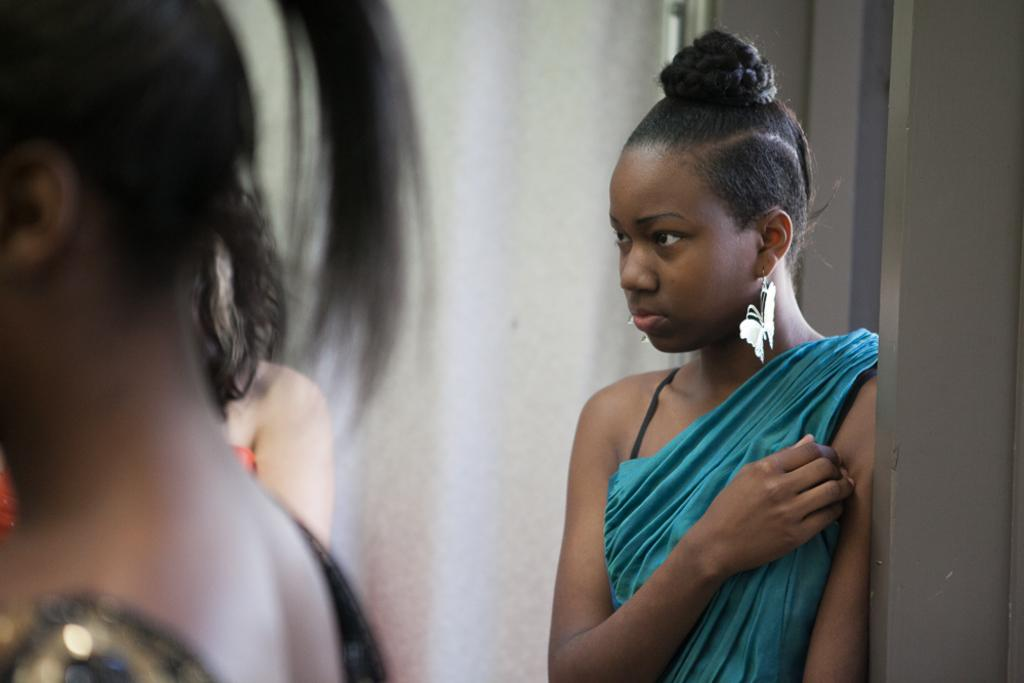Who is present in the image? There is a woman in the image. What is the woman wearing in her ears? The woman is wearing butterfly earrings. What can be seen in the background of the image? There is a wall in the background of the image. Where are the other persons located in the image? The persons are on the left side of the image. What is the woman's theory about the division of labor in the image? There is no information about the woman's theory or the division of labor in the image. 